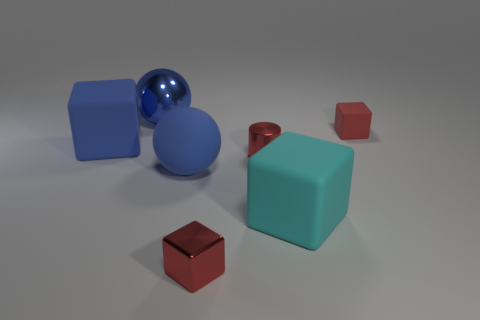Add 2 big cyan matte cubes. How many objects exist? 9 Subtract all balls. How many objects are left? 5 Add 7 red shiny blocks. How many red shiny blocks exist? 8 Subtract 2 blue balls. How many objects are left? 5 Subtract all large blue metal spheres. Subtract all small cubes. How many objects are left? 4 Add 4 small red rubber cubes. How many small red rubber cubes are left? 5 